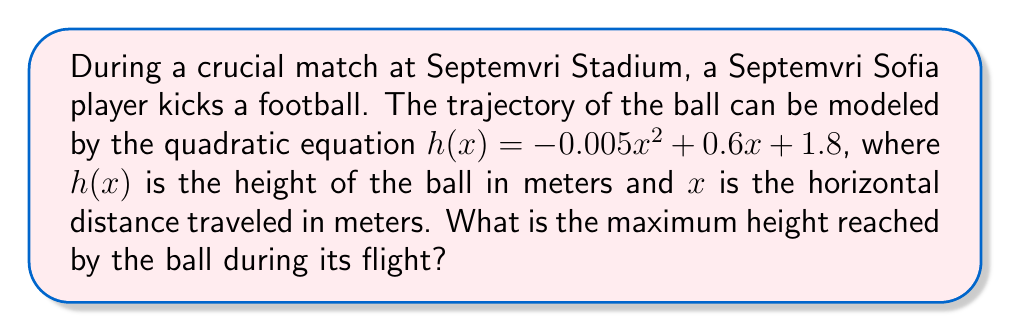Show me your answer to this math problem. To find the maximum height of the ball's trajectory, we need to follow these steps:

1) The quadratic equation is in the form $h(x) = ax^2 + bx + c$, where:
   $a = -0.005$
   $b = 0.6$
   $c = 1.8$

2) For a quadratic function, the x-coordinate of the vertex represents the point where the ball reaches its maximum height. We can find this using the formula:

   $x = -\frac{b}{2a}$

3) Substituting our values:
   
   $x = -\frac{0.6}{2(-0.005)} = -\frac{0.6}{-0.01} = 60$

4) Now that we know the x-coordinate of the vertex, we can find the maximum height by plugging this x-value back into our original equation:

   $h(60) = -0.005(60)^2 + 0.6(60) + 1.8$

5) Simplifying:
   
   $h(60) = -0.005(3600) + 36 + 1.8$
   $h(60) = -18 + 36 + 1.8$
   $h(60) = 19.8$

Therefore, the maximum height reached by the ball is 19.8 meters.
Answer: 19.8 meters 